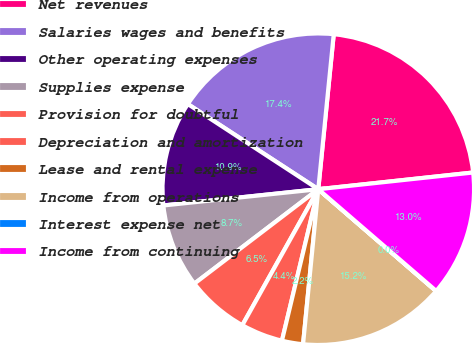Convert chart to OTSL. <chart><loc_0><loc_0><loc_500><loc_500><pie_chart><fcel>Net revenues<fcel>Salaries wages and benefits<fcel>Other operating expenses<fcel>Supplies expense<fcel>Provision for doubtful<fcel>Depreciation and amortization<fcel>Lease and rental expense<fcel>Income from operations<fcel>Interest expense net<fcel>Income from continuing<nl><fcel>21.71%<fcel>17.38%<fcel>10.87%<fcel>8.7%<fcel>6.53%<fcel>4.36%<fcel>2.19%<fcel>15.21%<fcel>0.02%<fcel>13.04%<nl></chart> 